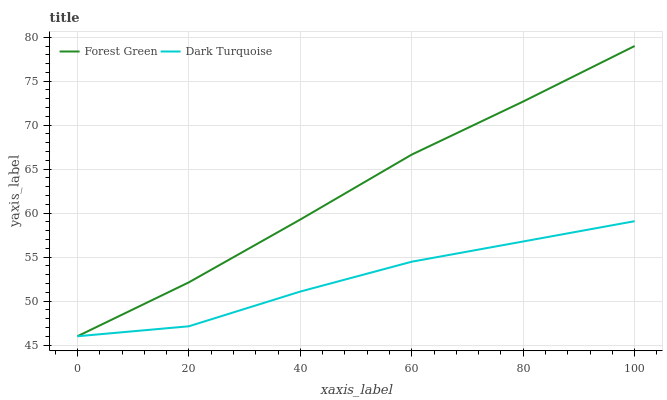Does Dark Turquoise have the minimum area under the curve?
Answer yes or no. Yes. Does Forest Green have the maximum area under the curve?
Answer yes or no. Yes. Does Forest Green have the minimum area under the curve?
Answer yes or no. No. Is Forest Green the smoothest?
Answer yes or no. Yes. Is Dark Turquoise the roughest?
Answer yes or no. Yes. Is Forest Green the roughest?
Answer yes or no. No. Does Dark Turquoise have the lowest value?
Answer yes or no. Yes. Does Forest Green have the highest value?
Answer yes or no. Yes. Does Dark Turquoise intersect Forest Green?
Answer yes or no. Yes. Is Dark Turquoise less than Forest Green?
Answer yes or no. No. Is Dark Turquoise greater than Forest Green?
Answer yes or no. No. 